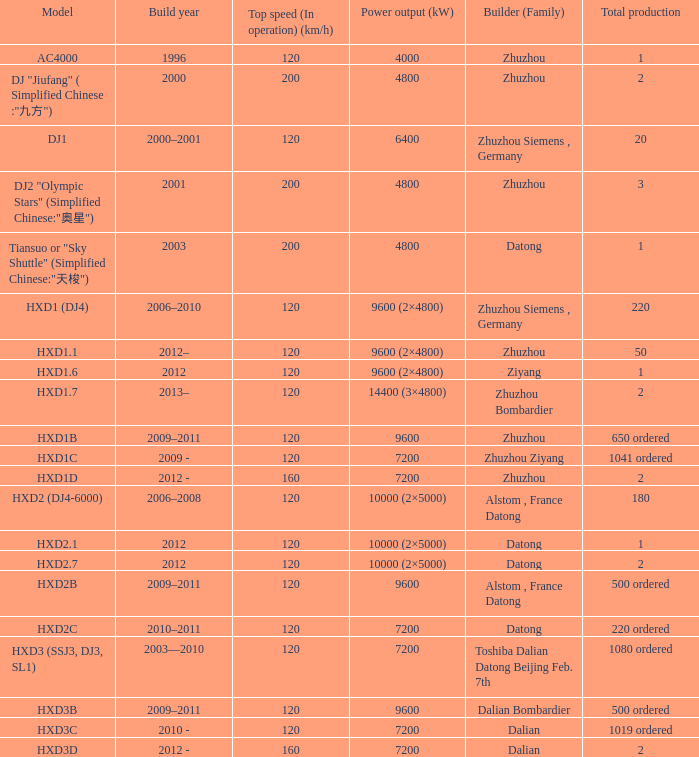I'm looking to parse the entire table for insights. Could you assist me with that? {'header': ['Model', 'Build year', 'Top speed (In operation) (km/h)', 'Power output (kW)', 'Builder (Family)', 'Total production'], 'rows': [['AC4000', '1996', '120', '4000', 'Zhuzhou', '1'], ['DJ "Jiufang" ( Simplified Chinese :"九方")', '2000', '200', '4800', 'Zhuzhou', '2'], ['DJ1', '2000–2001', '120', '6400', 'Zhuzhou Siemens , Germany', '20'], ['DJ2 "Olympic Stars" (Simplified Chinese:"奥星")', '2001', '200', '4800', 'Zhuzhou', '3'], ['Tiansuo or "Sky Shuttle" (Simplified Chinese:"天梭")', '2003', '200', '4800', 'Datong', '1'], ['HXD1 (DJ4)', '2006–2010', '120', '9600 (2×4800)', 'Zhuzhou Siemens , Germany', '220'], ['HXD1.1', '2012–', '120', '9600 (2×4800)', 'Zhuzhou', '50'], ['HXD1.6', '2012', '120', '9600 (2×4800)', 'Ziyang', '1'], ['HXD1.7', '2013–', '120', '14400 (3×4800)', 'Zhuzhou Bombardier', '2'], ['HXD1B', '2009–2011', '120', '9600', 'Zhuzhou', '650 ordered'], ['HXD1C', '2009 -', '120', '7200', 'Zhuzhou Ziyang', '1041 ordered'], ['HXD1D', '2012 -', '160', '7200', 'Zhuzhou', '2'], ['HXD2 (DJ4-6000)', '2006–2008', '120', '10000 (2×5000)', 'Alstom , France Datong', '180'], ['HXD2.1', '2012', '120', '10000 (2×5000)', 'Datong', '1'], ['HXD2.7', '2012', '120', '10000 (2×5000)', 'Datong', '2'], ['HXD2B', '2009–2011', '120', '9600', 'Alstom , France Datong', '500 ordered'], ['HXD2C', '2010–2011', '120', '7200', 'Datong', '220 ordered'], ['HXD3 (SSJ3, DJ3, SL1)', '2003—2010', '120', '7200', 'Toshiba Dalian Datong Beijing Feb. 7th', '1080 ordered'], ['HXD3B', '2009–2011', '120', '9600', 'Dalian Bombardier', '500 ordered'], ['HXD3C', '2010 -', '120', '7200', 'Dalian', '1019 ordered'], ['HXD3D', '2012 -', '160', '7200', 'Dalian', '2']]} What is the power output (kw) of constructor zhuzhou, model hxd1d, having a total production of 2? 7200.0. 